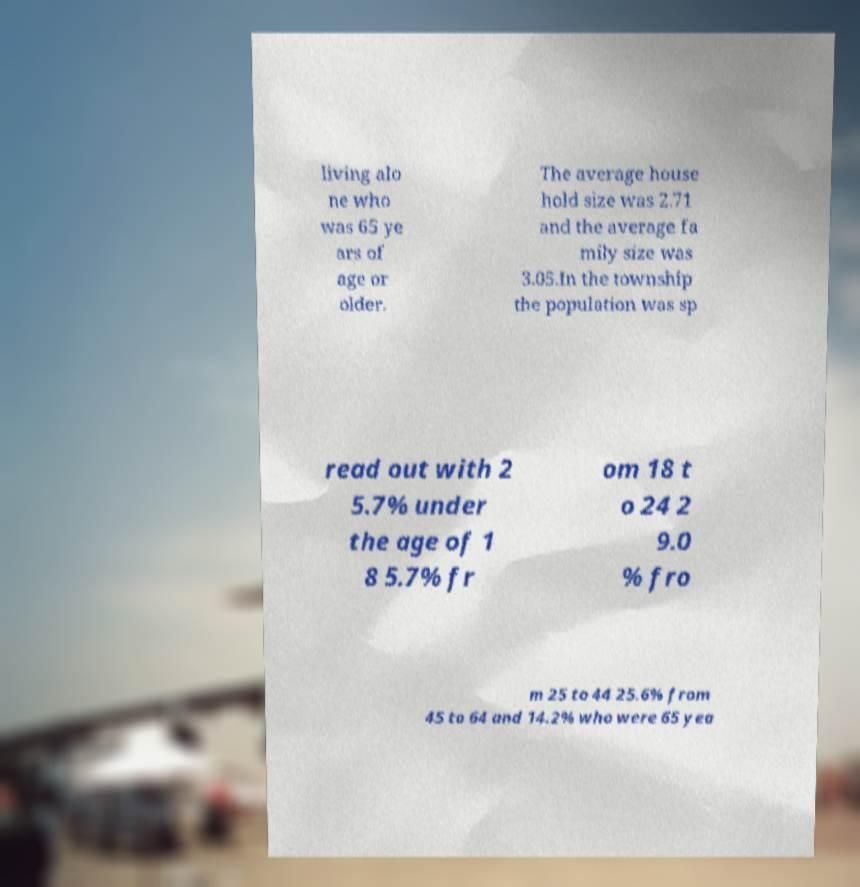I need the written content from this picture converted into text. Can you do that? living alo ne who was 65 ye ars of age or older. The average house hold size was 2.71 and the average fa mily size was 3.05.In the township the population was sp read out with 2 5.7% under the age of 1 8 5.7% fr om 18 t o 24 2 9.0 % fro m 25 to 44 25.6% from 45 to 64 and 14.2% who were 65 yea 